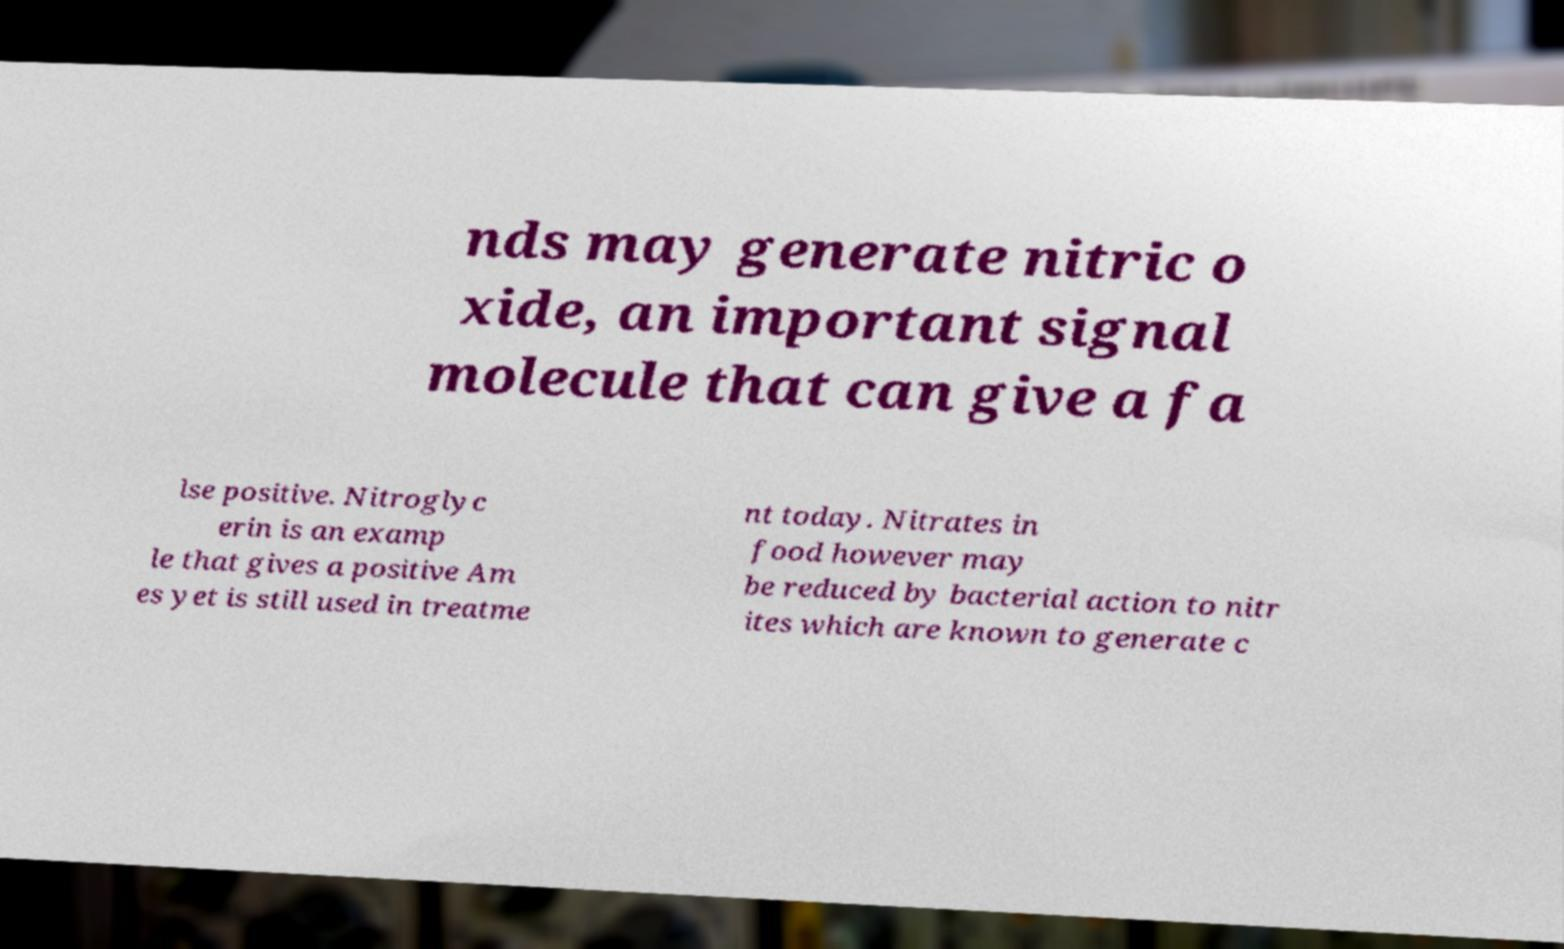Please identify and transcribe the text found in this image. nds may generate nitric o xide, an important signal molecule that can give a fa lse positive. Nitroglyc erin is an examp le that gives a positive Am es yet is still used in treatme nt today. Nitrates in food however may be reduced by bacterial action to nitr ites which are known to generate c 